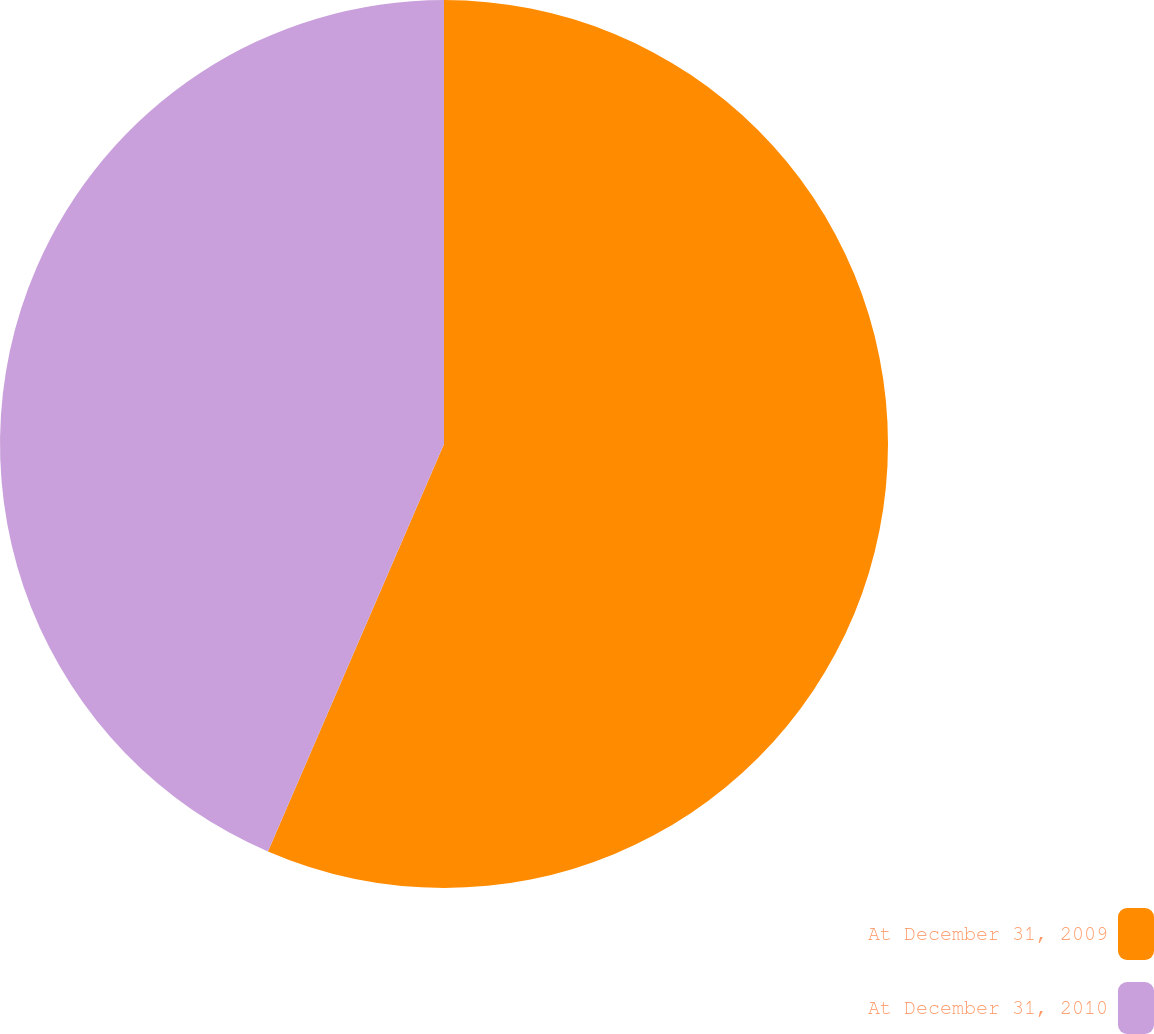Convert chart to OTSL. <chart><loc_0><loc_0><loc_500><loc_500><pie_chart><fcel>At December 31, 2009<fcel>At December 31, 2010<nl><fcel>56.49%<fcel>43.51%<nl></chart> 